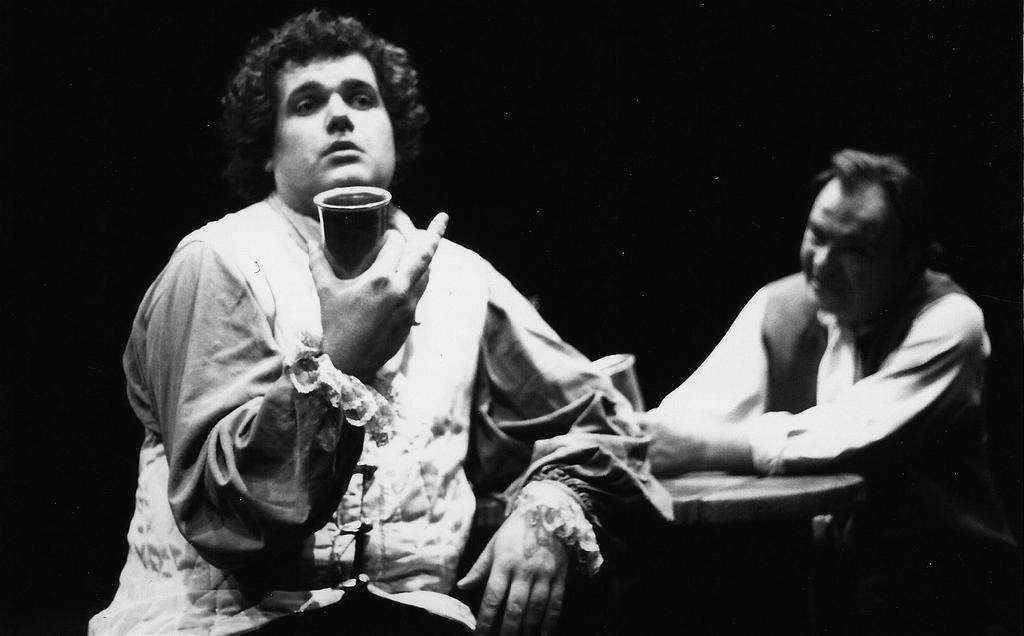How many people are in the image? There are two persons in the image. What is one person holding in the image? One person is holding a glass. What can be observed about the background of the image? The background of the image is dark. What type of apparel is the person wearing in the image? The provided facts do not mention any specific apparel worn by the person in the image. Can you tell me how many plates are visible in the image? There is no mention of plates in the provided facts, so it cannot be determined from the image. 